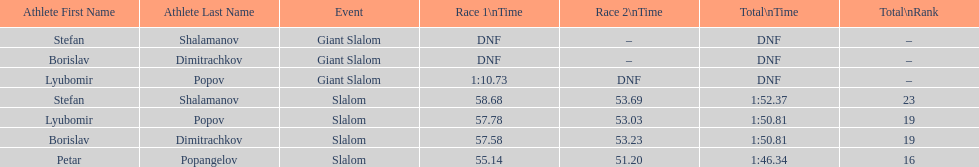Which athlete had a race time above 1:00? Lyubomir Popov. 